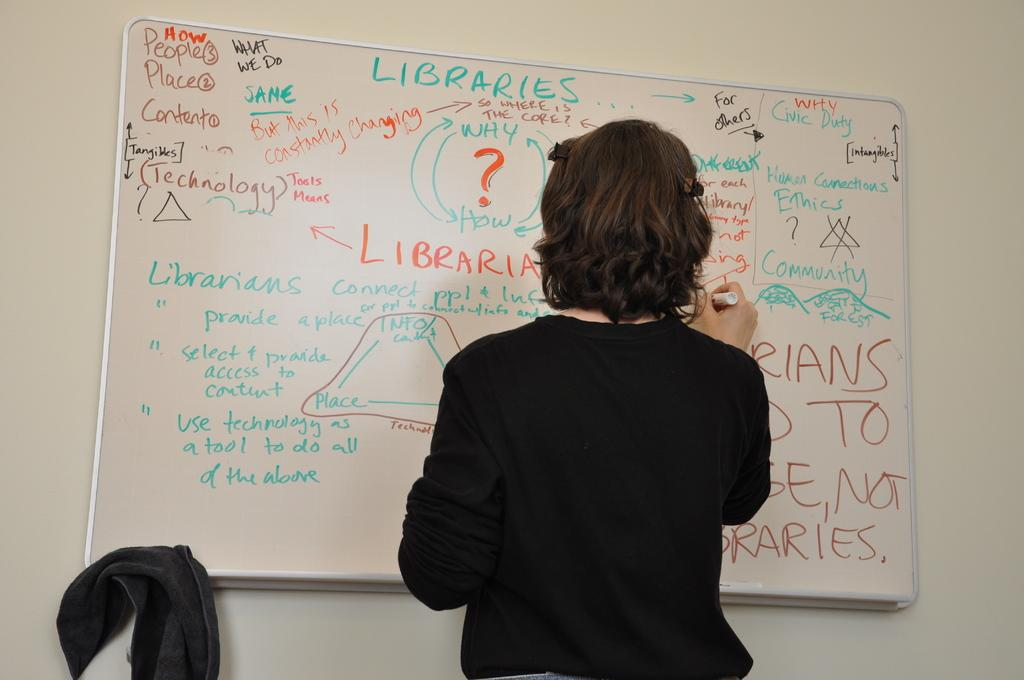Provide a one-sentence caption for the provided image. a woman writing on a white board with words Libraries on it. 